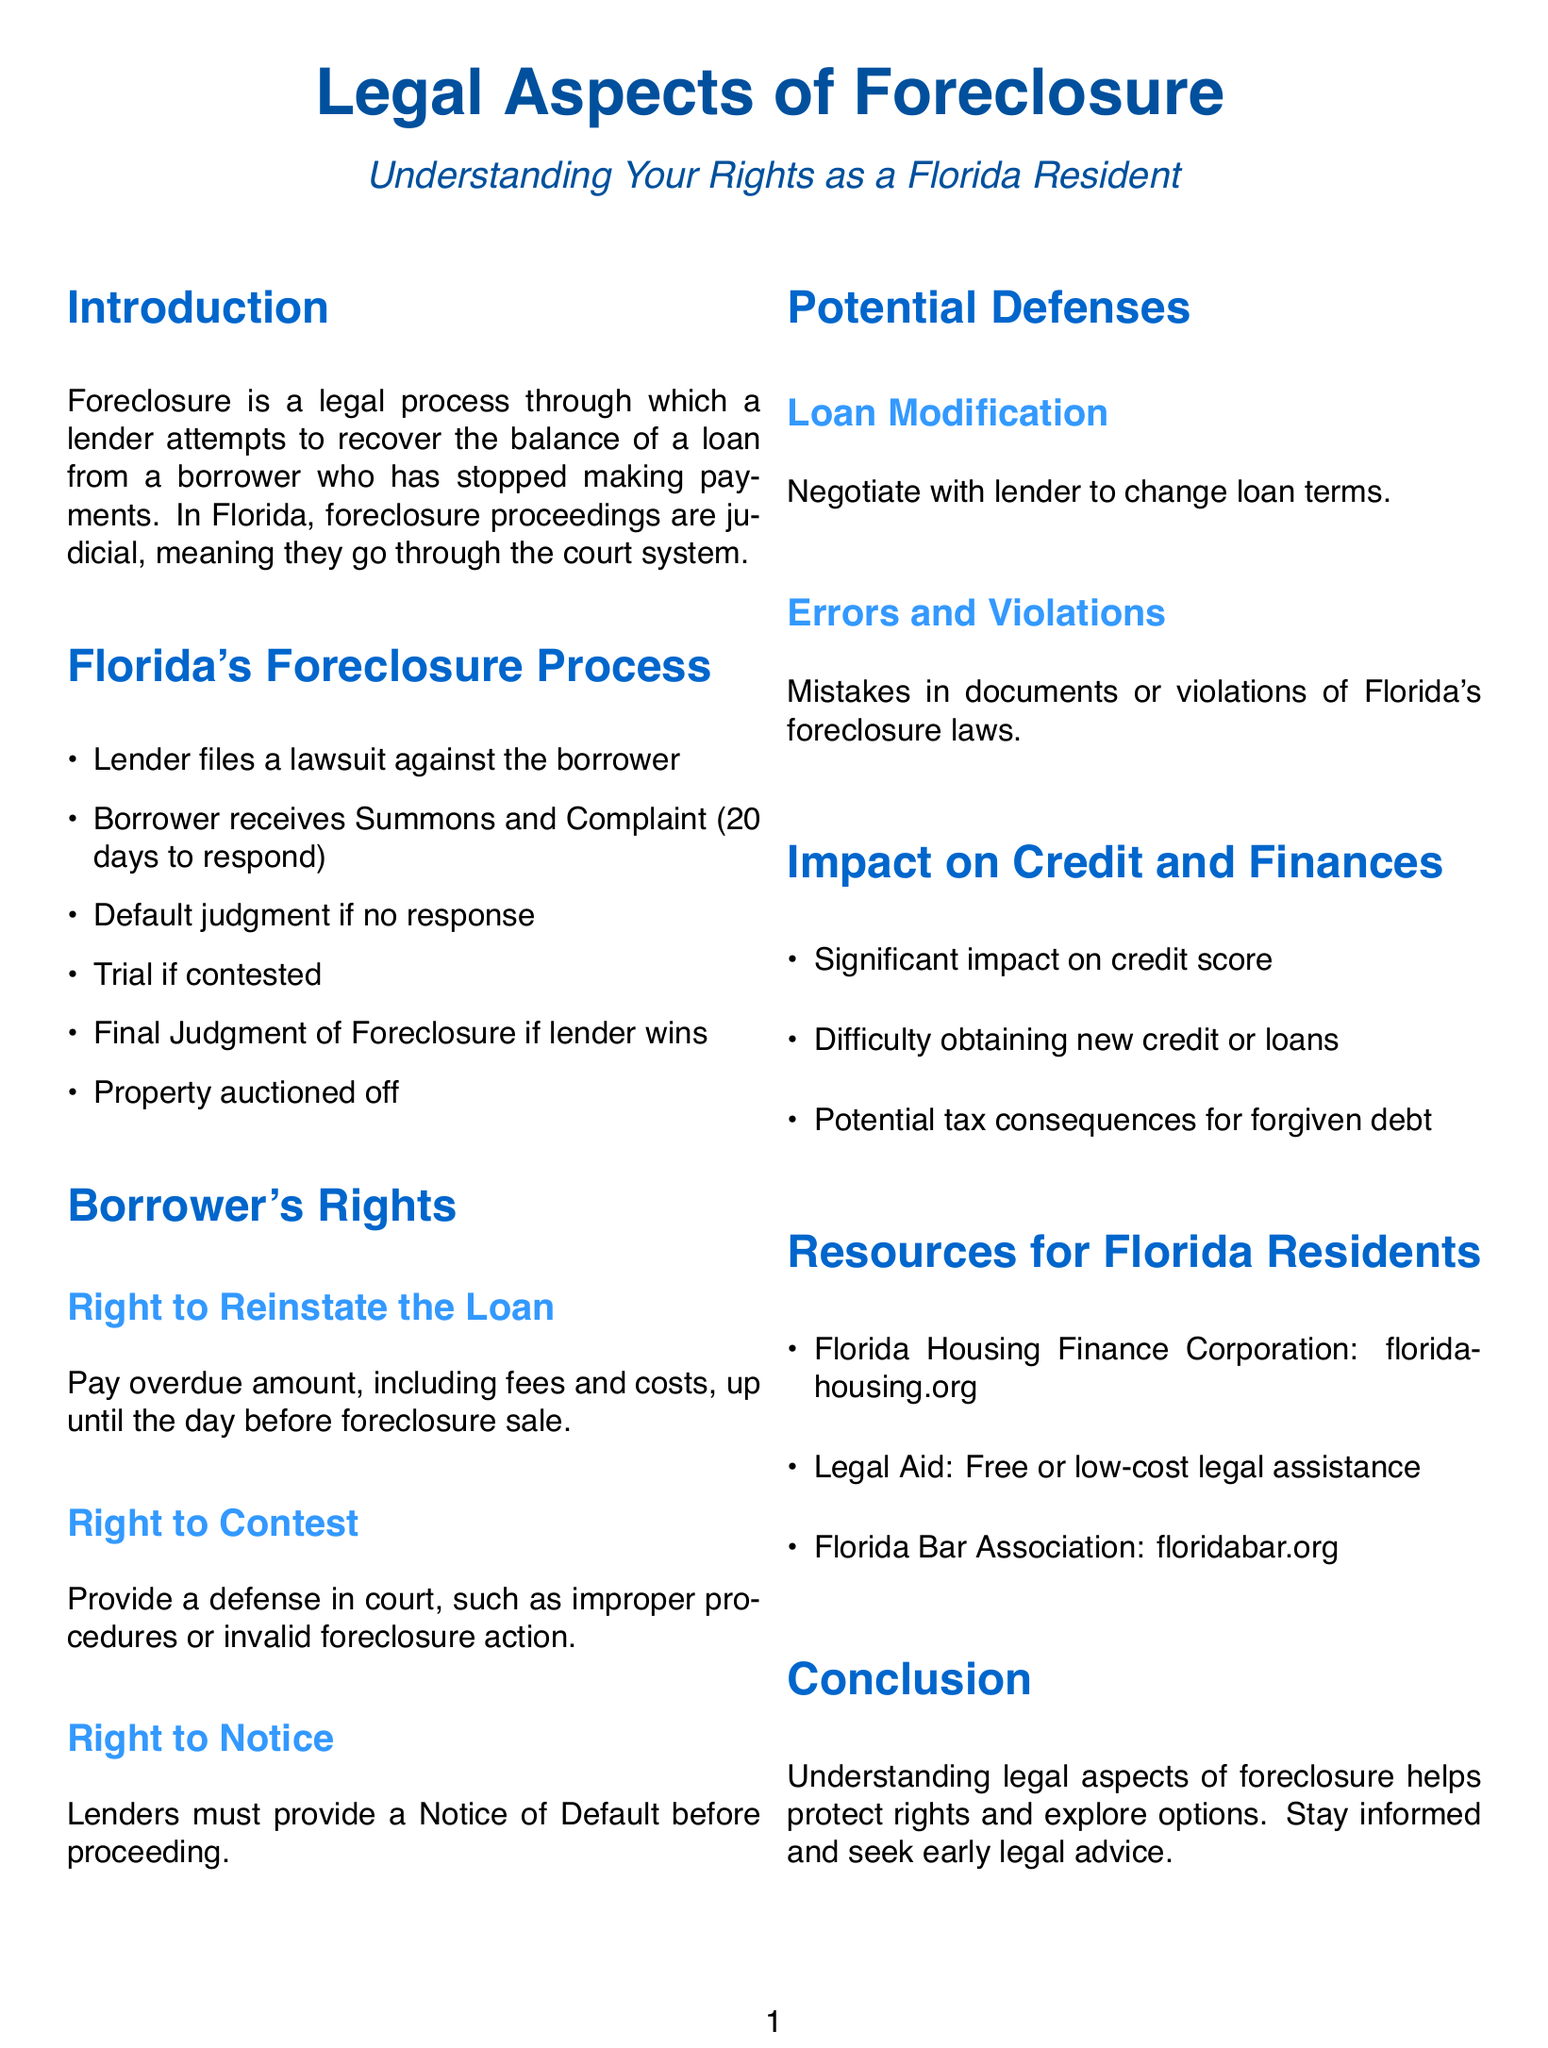What type of foreclosure process does Florida have? The document states that foreclosure proceedings in Florida are judicial, meaning they go through the court system.
Answer: Judicial What is the time frame for a borrower to respond to a Summons and Complaint? According to the document, a borrower has 20 days to respond once they receive the Summons and Complaint.
Answer: 20 days What right allows a borrower to pay overdue amounts before the foreclosure sale? The document mentions the Right to Reinstate the Loan as the right that allows this action.
Answer: Right to Reinstate the Loan What organization provides free or low-cost legal assistance in Florida? The document indicates that Legal Aid offers free or low-cost legal assistance to residents.
Answer: Legal Aid What is a potential defense against foreclosure mentioned in the document? The document lists Loan Modification as one of the potential defenses a borrower can use.
Answer: Loan Modification What can significantly impact a debtor's credit score? The document emphasizes that foreclosure has a significant impact on a borrower's credit score.
Answer: Foreclosure What must lenders provide before proceeding with foreclosure? The document states that lenders are required to provide a Notice of Default.
Answer: Notice of Default 